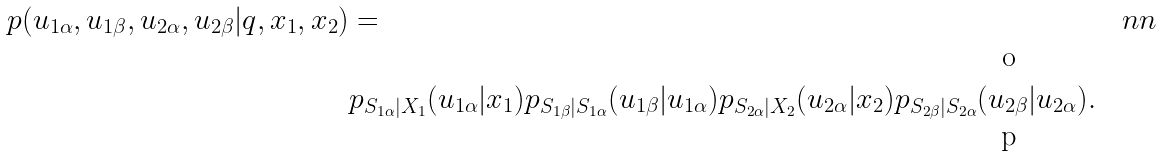<formula> <loc_0><loc_0><loc_500><loc_500>p ( u _ { 1 \alpha } , u _ { 1 \beta } , u _ { 2 \alpha } , u _ { 2 \beta } | q , x _ { 1 } , x _ { 2 } ) & = & \ n n \\ & p _ { S _ { 1 \alpha } | X _ { 1 } } ( u _ { 1 \alpha } | x _ { 1 } ) p _ { S _ { 1 \beta } | S _ { 1 \alpha } } ( u _ { 1 \beta } | u _ { 1 \alpha } ) p _ { S _ { 2 \alpha } | X _ { 2 } } ( u _ { 2 \alpha } | x _ { 2 } ) p _ { S _ { 2 \beta } | S _ { 2 \alpha } } ( u _ { 2 \beta } | u _ { 2 \alpha } ) .</formula> 